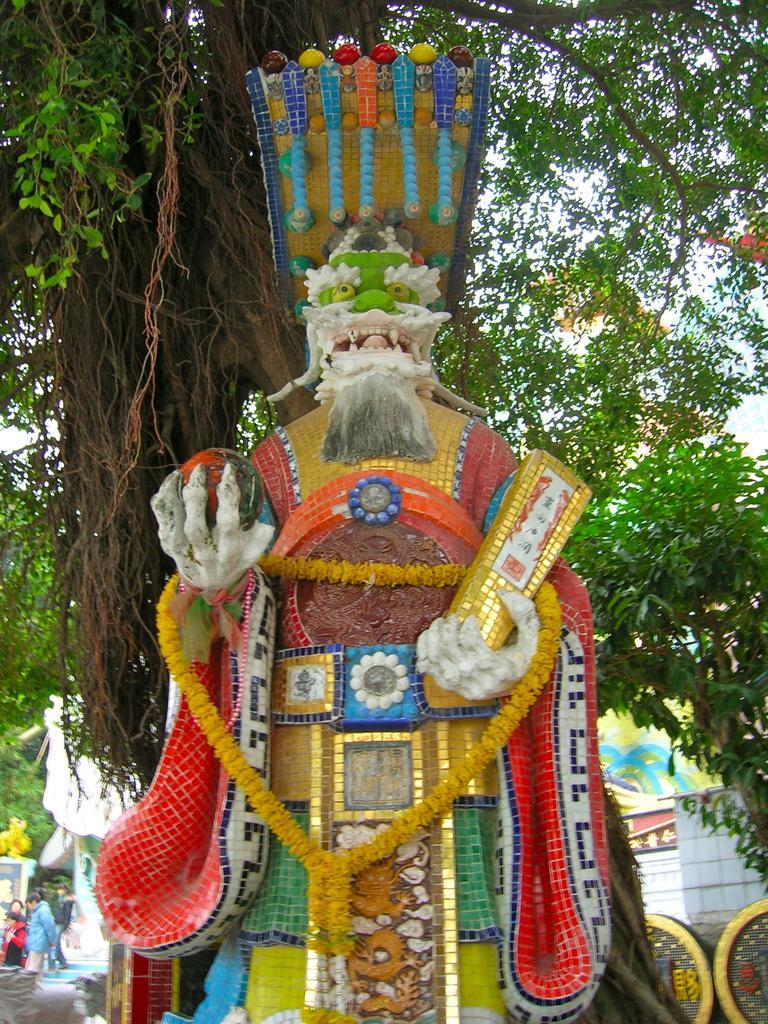Describe this image in one or two sentences. In this image in the center there is one statue, in the background there are some trees, houses and some persons are walking. 